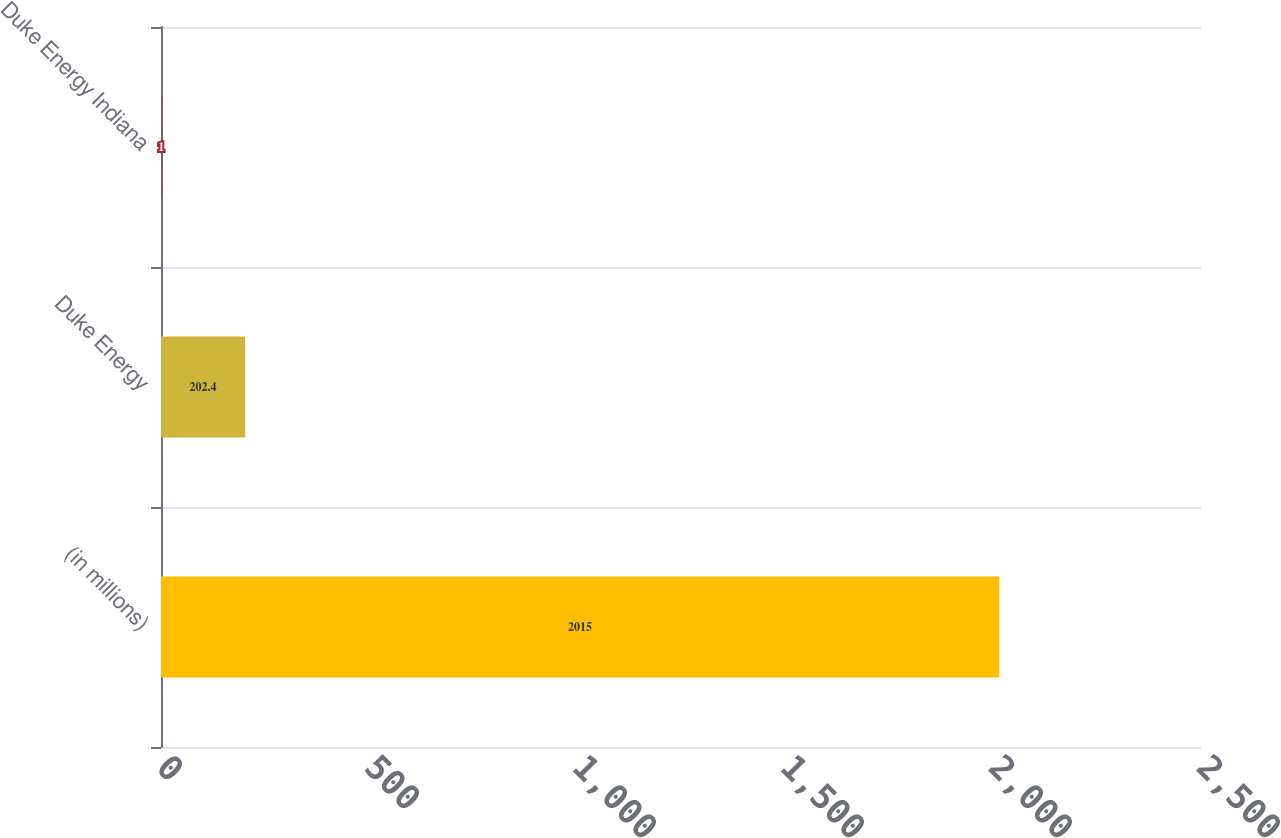Convert chart. <chart><loc_0><loc_0><loc_500><loc_500><bar_chart><fcel>(in millions)<fcel>Duke Energy<fcel>Duke Energy Indiana<nl><fcel>2015<fcel>202.4<fcel>1<nl></chart> 